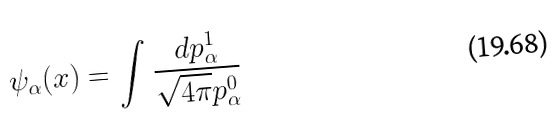<formula> <loc_0><loc_0><loc_500><loc_500>\psi _ { \alpha } ( x ) = \int \frac { d p _ { \alpha } ^ { 1 } } { \sqrt { 4 \pi } p _ { \alpha } ^ { 0 } }</formula> 